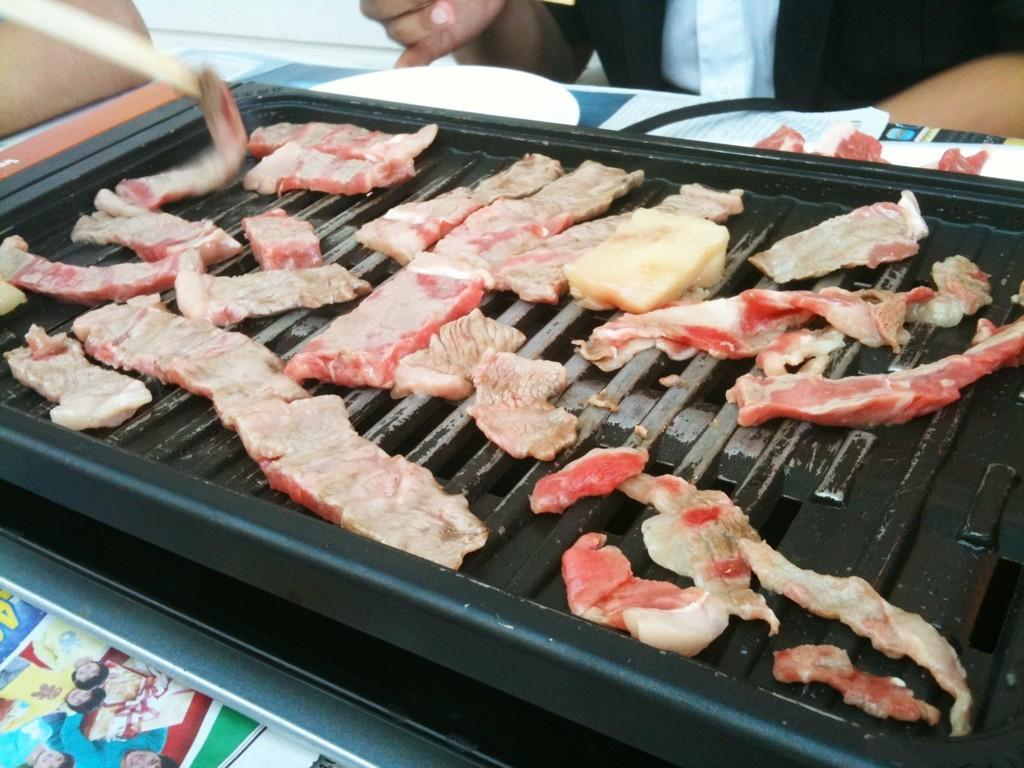What is the main object in the image? There is a barbecue in the image. What is being done to the eatable things in the image? The eatable things are placed on the barbecue. Whose hands are visible in the image? Human hands are visible at the top of the image. What is used to serve the cooked food in the image? There is a plate in the image. What is the purpose of the wire in the image? The wire is not described in the facts, so we cannot determine its purpose. What type of paper is present in the image? There are papers in the image, but their specific type is not mentioned. How many trees can be seen in the image? There is no mention of trees in the image, so we cannot determine their presence or number. What type of fly is buzzing around the barbecue in the image? There is no mention of a fly in the image, so we cannot determine its presence or type. 